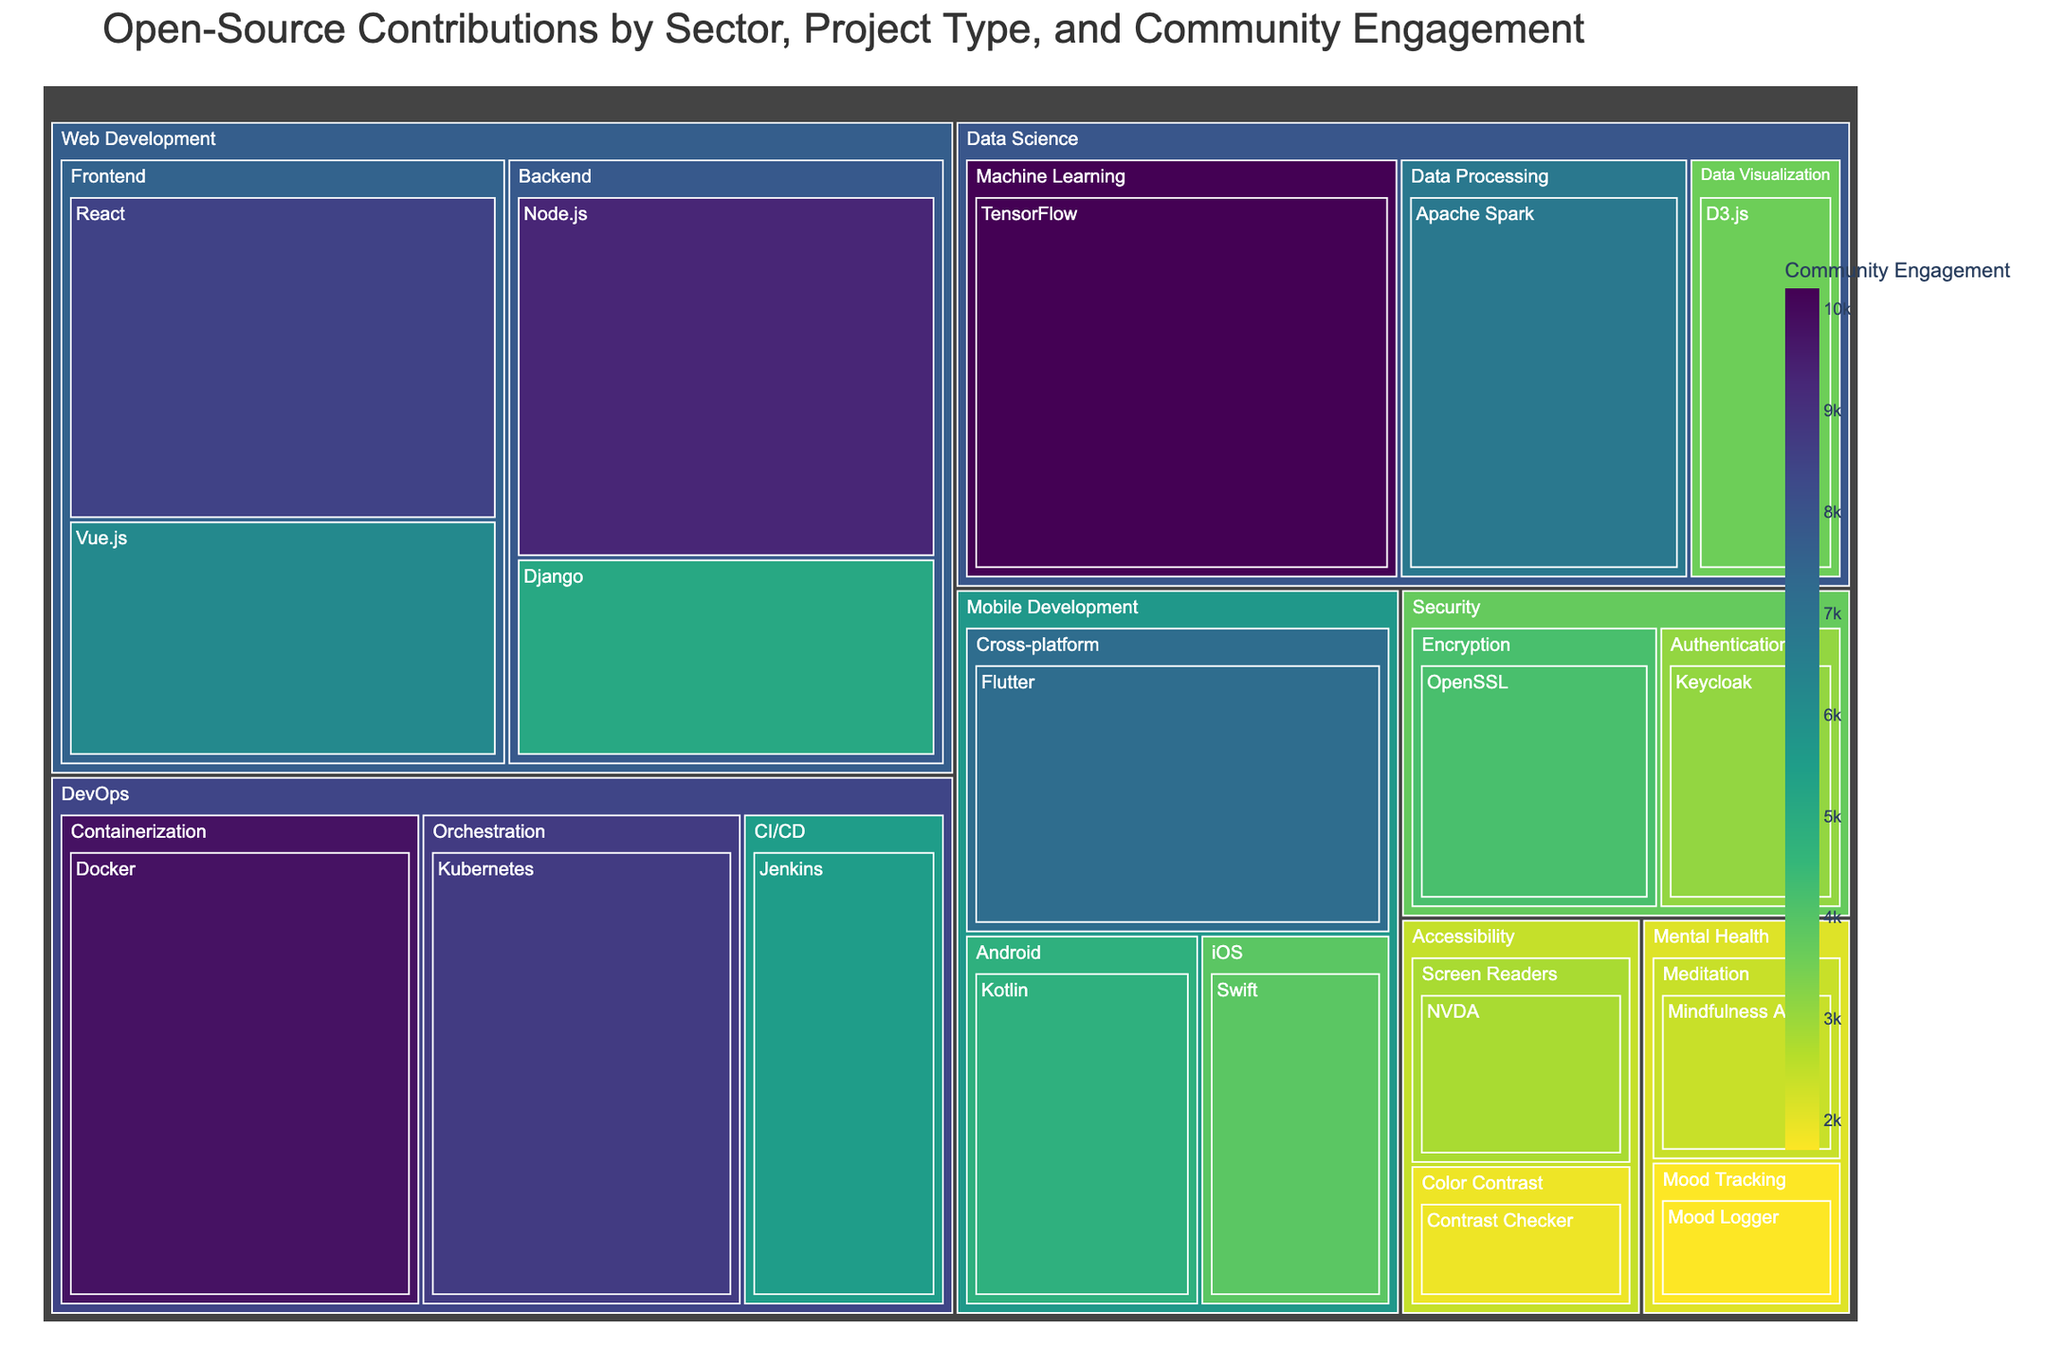Which sector has the highest community engagement for a single project? Look at the sectors and identify the project with the highest community engagement value. TensorFlow under Data Science has the highest engagement of 10,200.
Answer: Data Science What is the total community engagement for projects in the DevOps sector? Sum the community engagement values for Docker (9,800), Kubernetes (8,700), and Jenkins (5,500). 9,800 + 8,700 + 5,500 = 24,000.
Answer: 24,000 Which project has higher community engagement, React in Web Development or TensorFlow in Data Science? Compare the community engagement values of React (8,500) and TensorFlow (10,200). TensorFlow has a higher value.
Answer: TensorFlow Which sector has the lowest average community engagement across its projects? Calculate the average engagement for each sector, then find the smallest value. Accessibility: (2,800 + 1,900) / 2 = 2,350, which is the lowest average among all sectors.
Answer: Accessibility How many projects in the Security sector exceed 3,000 in community engagement? Check the community engagement values for projects in the Security sector: OpenSSL (4,200) and Keycloak (3,100). Both exceed 3,000, so the number is 2.
Answer: 2 What is the difference in community engagement between the most popular project in Web Development and Mobile Development? Identify the most popular projects: Node.js (9,300) in Web Development and Flutter (7,200) in Mobile Development. Find the difference: 9,300 - 7,200 = 2,100.
Answer: 2,100 Which sector includes projects related to both Meditation and Mood Tracking? Observe the mentioned project types in the Treemap. Both Meditation and Mood Tracking are under the Mental Health sector.
Answer: Mental Health What is the total community engagement for cloud-related technologies within DevOps? Sum the community engagement values for Kubernetes (8,700), Docker (9,800), and Jenkins (5,500). 8,700 + 9,800 + 5,500 = 24,000.
Answer: 24,000 Which Frontend project in the Web Development sector has higher community engagement? Compare the community engagement values of React (8,500) and Vue.js (6,200). React has a higher value.
Answer: React What is the community engagement difference between NVDA and Contrast Checker in the Accessibility sector? Check the values for NVDA (2,800) and Contrast Checker (1,900). Subtract to find the difference: 2,800 - 1,900 = 900.
Answer: 900 